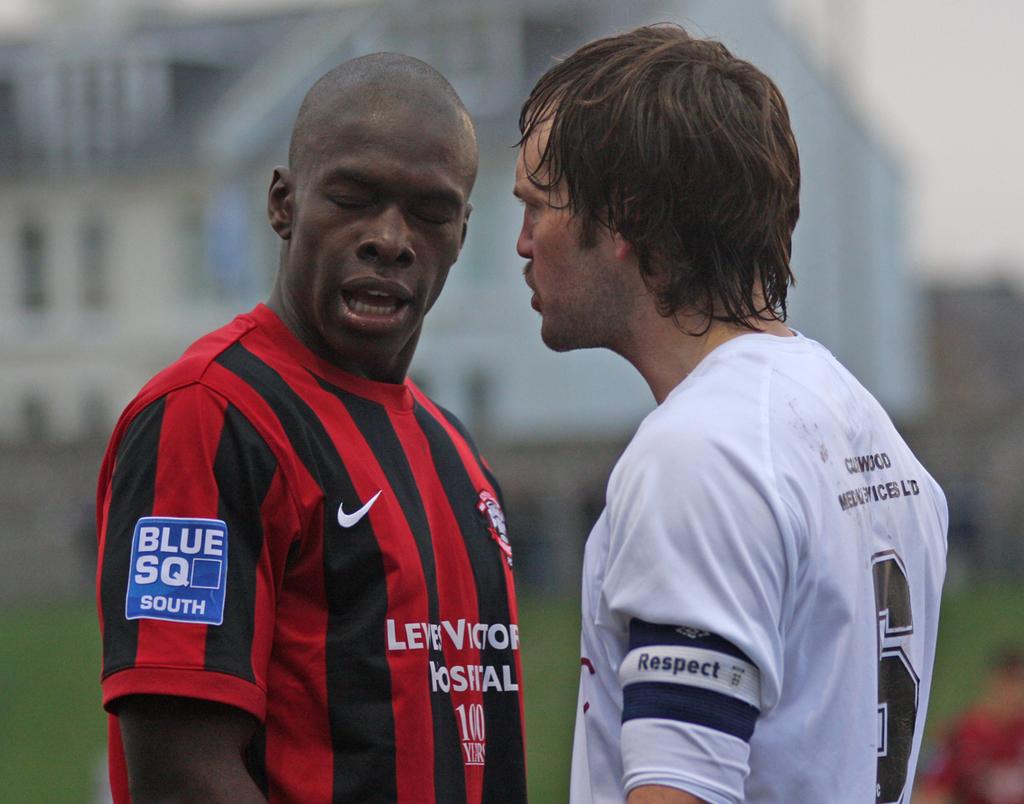What is the word on the bottom of the blue patch?
Keep it short and to the point. South. What number on the white jersey?
Keep it short and to the point. 6. 